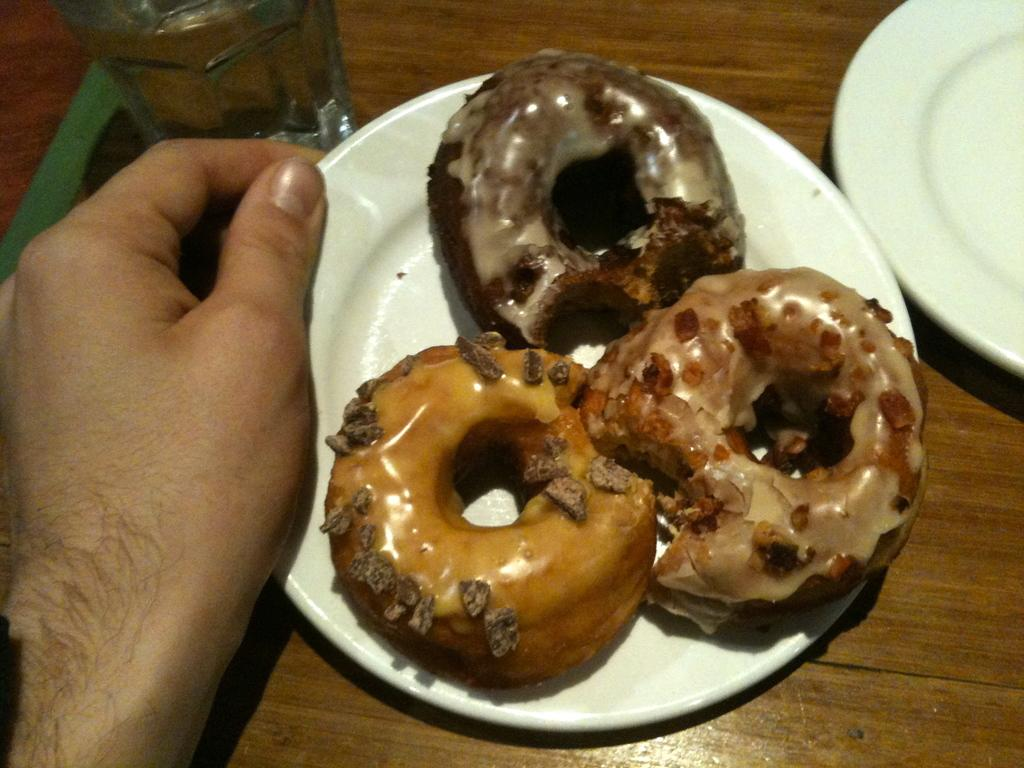What type of food can be seen on the plate in the image? There are three donuts on a plate in the image. Who is holding the plate with donuts? The plate with donuts is being carried by a person. What else can be seen on the table in the image? There is another plate and a glass in the image. Where are all of these objects located? All of these objects are placed on a table. What type of stocking is visible on the person carrying the plate of donuts? There is no mention of stockings or any clothing in the image, so it cannot be determined if any stockings are visible. 